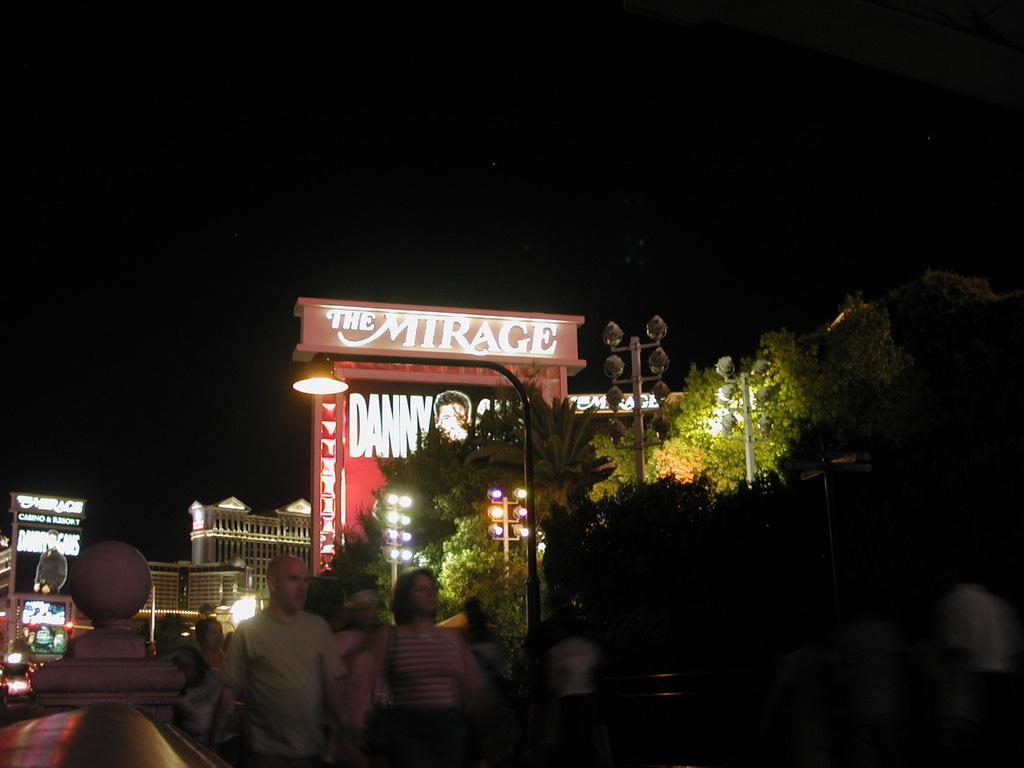What type of structures are visible in the image? There are buildings in the image. What is happening in front of the buildings? There are people in front of the buildings. What other objects can be seen in the image? There are light poles in the image. What type of vegetation is present in the image? There are trees in the image. How would you describe the lighting in the image? The background of the image is dark. Can you tell me how many people are trying to crush the trees in the image? There is no indication in the image that anyone is trying to crush the trees; people are simply standing in front of the buildings. What type of attack is happening in the image? There is no attack depicted in the image; it shows buildings, people, light poles, trees, and a dark background. 